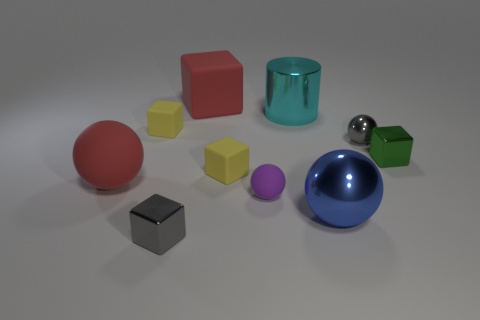Subtract all cylinders. How many objects are left? 9 Subtract all large blue spheres. How many spheres are left? 3 Add 2 gray cubes. How many gray cubes are left? 3 Add 2 small green metallic objects. How many small green metallic objects exist? 3 Subtract all red spheres. How many spheres are left? 3 Subtract 0 blue cylinders. How many objects are left? 10 Subtract 5 cubes. How many cubes are left? 0 Subtract all green blocks. Subtract all brown balls. How many blocks are left? 4 Subtract all blue spheres. How many blue blocks are left? 0 Subtract all big red matte cubes. Subtract all small gray things. How many objects are left? 7 